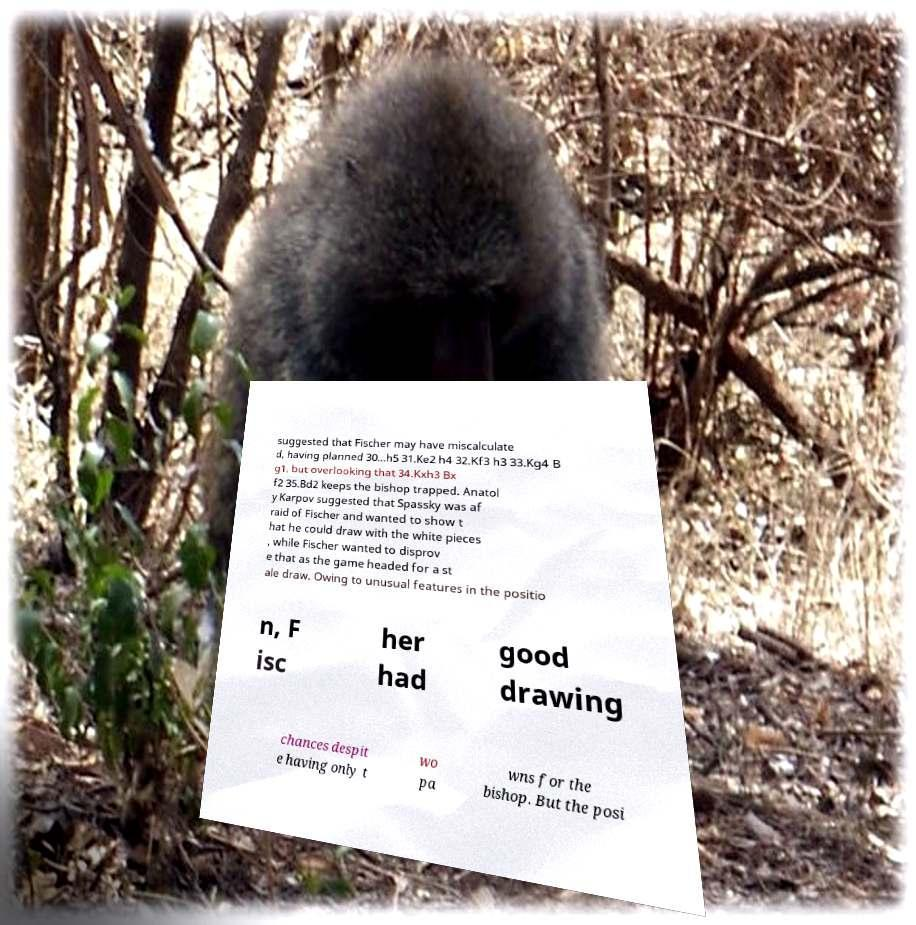I need the written content from this picture converted into text. Can you do that? suggested that Fischer may have miscalculate d, having planned 30...h5 31.Ke2 h4 32.Kf3 h3 33.Kg4 B g1, but overlooking that 34.Kxh3 Bx f2 35.Bd2 keeps the bishop trapped. Anatol y Karpov suggested that Spassky was af raid of Fischer and wanted to show t hat he could draw with the white pieces , while Fischer wanted to disprov e that as the game headed for a st ale draw. Owing to unusual features in the positio n, F isc her had good drawing chances despit e having only t wo pa wns for the bishop. But the posi 